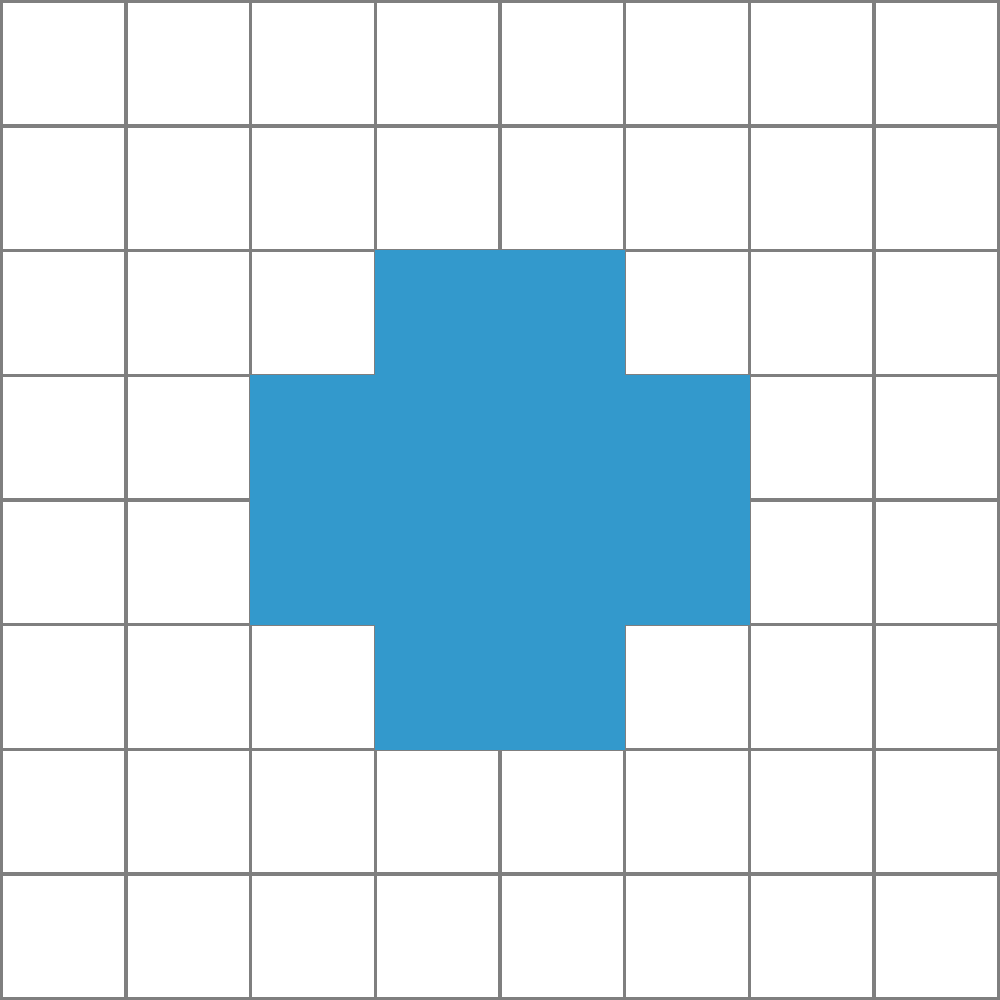Consider the pixel art character sprite shown above. What is the order of its symmetry group? Assume that only rotations and reflections that map the sprite onto itself while preserving the pixel grid are considered valid symmetries. To determine the order of the symmetry group, we need to identify all the symmetry operations that leave the sprite unchanged:

1. Identity: The sprite remains unchanged (always a symmetry).

2. Rotations:
   - 180° rotation: The sprite is symmetric when rotated 180°.
   - 90° and 270° rotations: These do not preserve the sprite's shape.

3. Reflections:
   - Vertical reflection: The sprite is symmetric about its vertical axis.
   - Horizontal reflection: The sprite is not symmetric about its horizontal axis.
   - Diagonal reflections: The sprite is not symmetric about any diagonal axes.

In total, we have identified 4 symmetry operations:
1. Identity
2. 180° rotation
3. Vertical reflection
4. Vertical reflection followed by 180° rotation (equivalent to horizontal reflection composed with 180° rotation)

These 4 operations form a group under composition, specifically the Klein four-group ($V_4$).

The order of a group is the number of elements it contains. Therefore, the order of the symmetry group for this pixel art character sprite is 4.
Answer: 4 